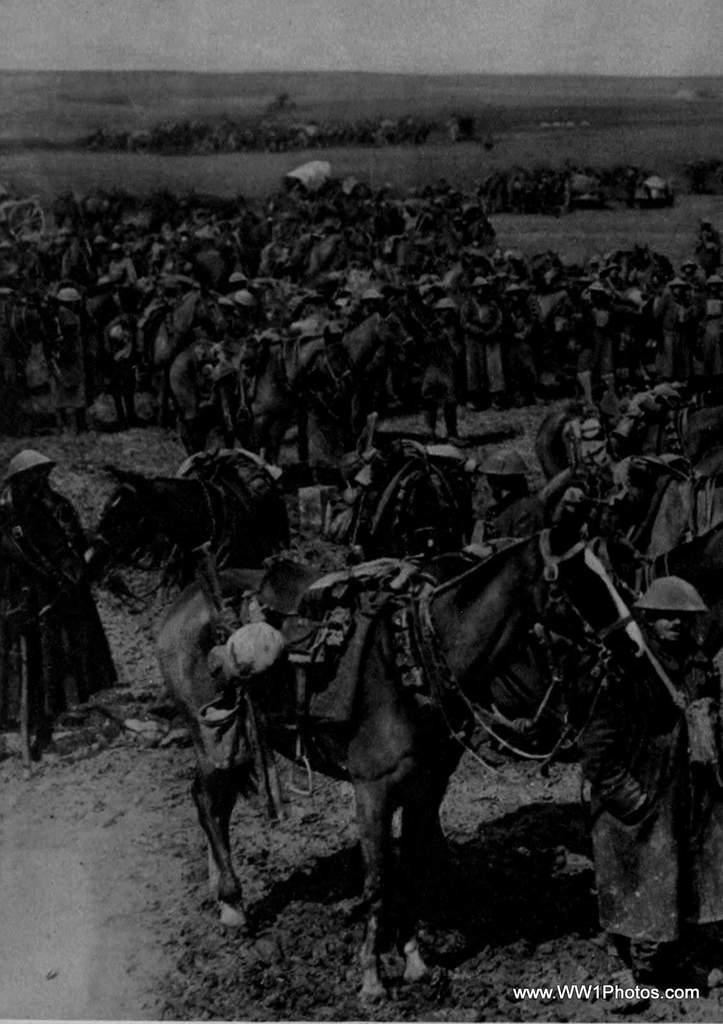What animals are present in the image? There are horses in the image. Are there any people with the horses? Yes, there are people with the horses in the image. What is the color scheme of the image? The image is black and white. Is there any text visible in the image? Yes, there is some text in the right bottom corner of the image. How many gloves can be seen on the horses in the image? There are no gloves visible on the horses in the image. What type of lead is being used to control the horses in the image? There is no lead present in the image; the horses are with people, but no specific method of control is depicted. 